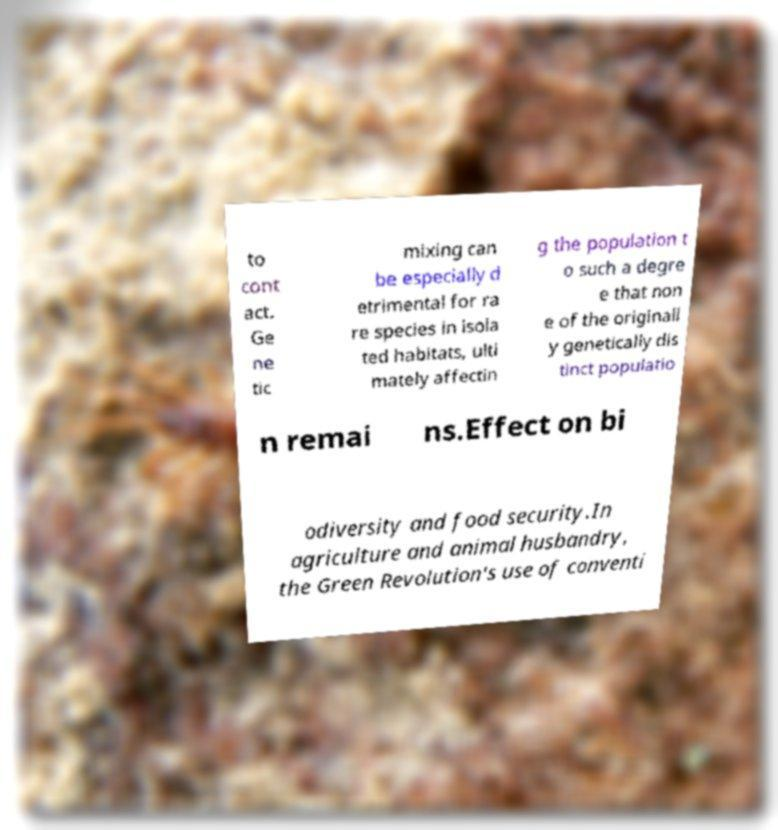What messages or text are displayed in this image? I need them in a readable, typed format. to cont act. Ge ne tic mixing can be especially d etrimental for ra re species in isola ted habitats, ulti mately affectin g the population t o such a degre e that non e of the originall y genetically dis tinct populatio n remai ns.Effect on bi odiversity and food security.In agriculture and animal husbandry, the Green Revolution's use of conventi 